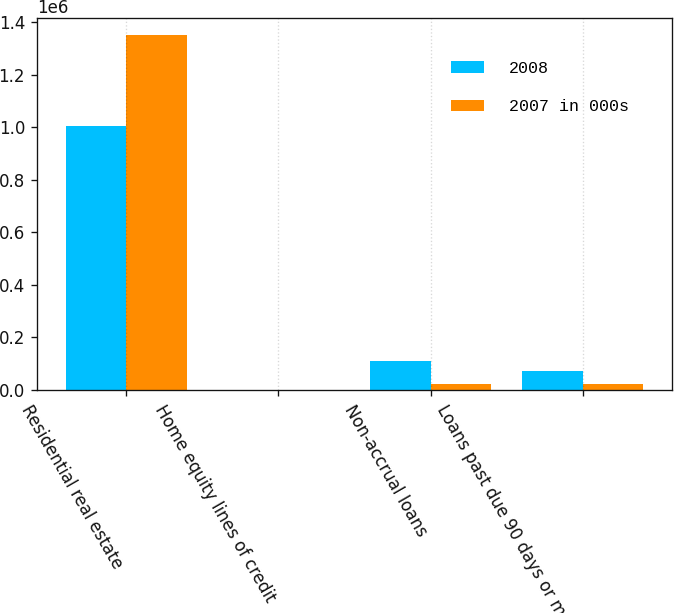<chart> <loc_0><loc_0><loc_500><loc_500><stacked_bar_chart><ecel><fcel>Residential real estate<fcel>Home equity lines of credit<fcel>Non-accrual loans<fcel>Loans past due 90 days or more<nl><fcel>2008<fcel>1.00428e+06<fcel>357<fcel>110759<fcel>73600<nl><fcel>2007 in 000s<fcel>1.35061e+06<fcel>280<fcel>22909<fcel>22909<nl></chart> 